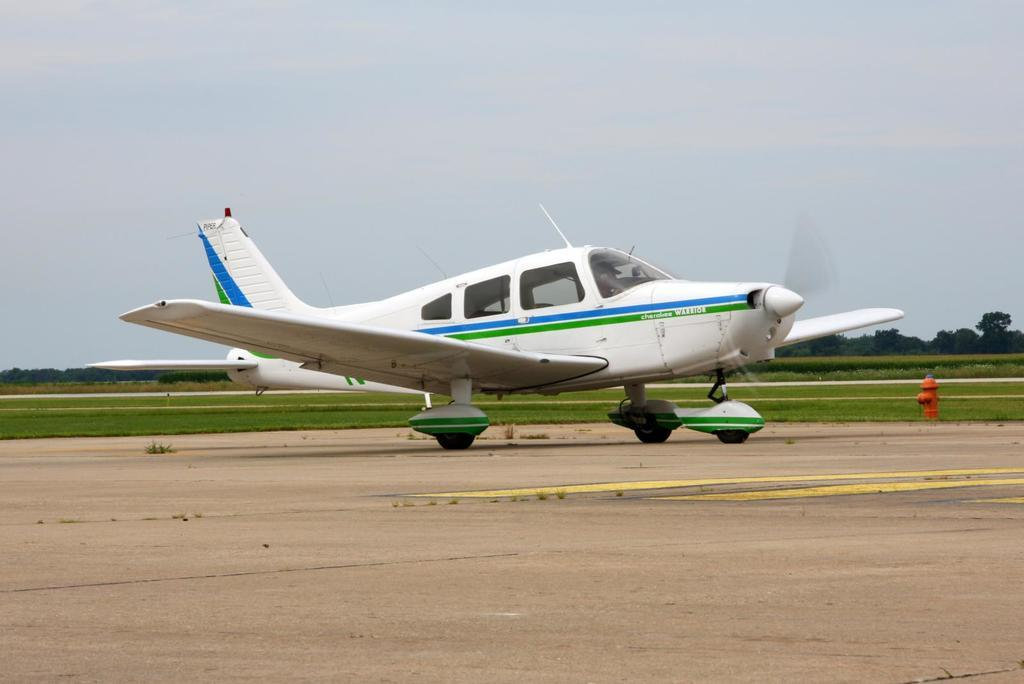What is the person in the image doing? There is a person inside an aircraft in the image. What can be observed about the aircraft's position? The aircraft is on a path. What type of vegetation is visible in the background of the image? There are trees and grass in the background of the image. What is visible in the sky in the image? The sky is visible in the background of the image. What object can be seen on the right side of the image? There is a hydrant on the right side of the image. How does the needle move in the image? There is no needle present in the image. What is the birth rate of the trees in the image? The image does not provide information about the birth rate of the trees. 